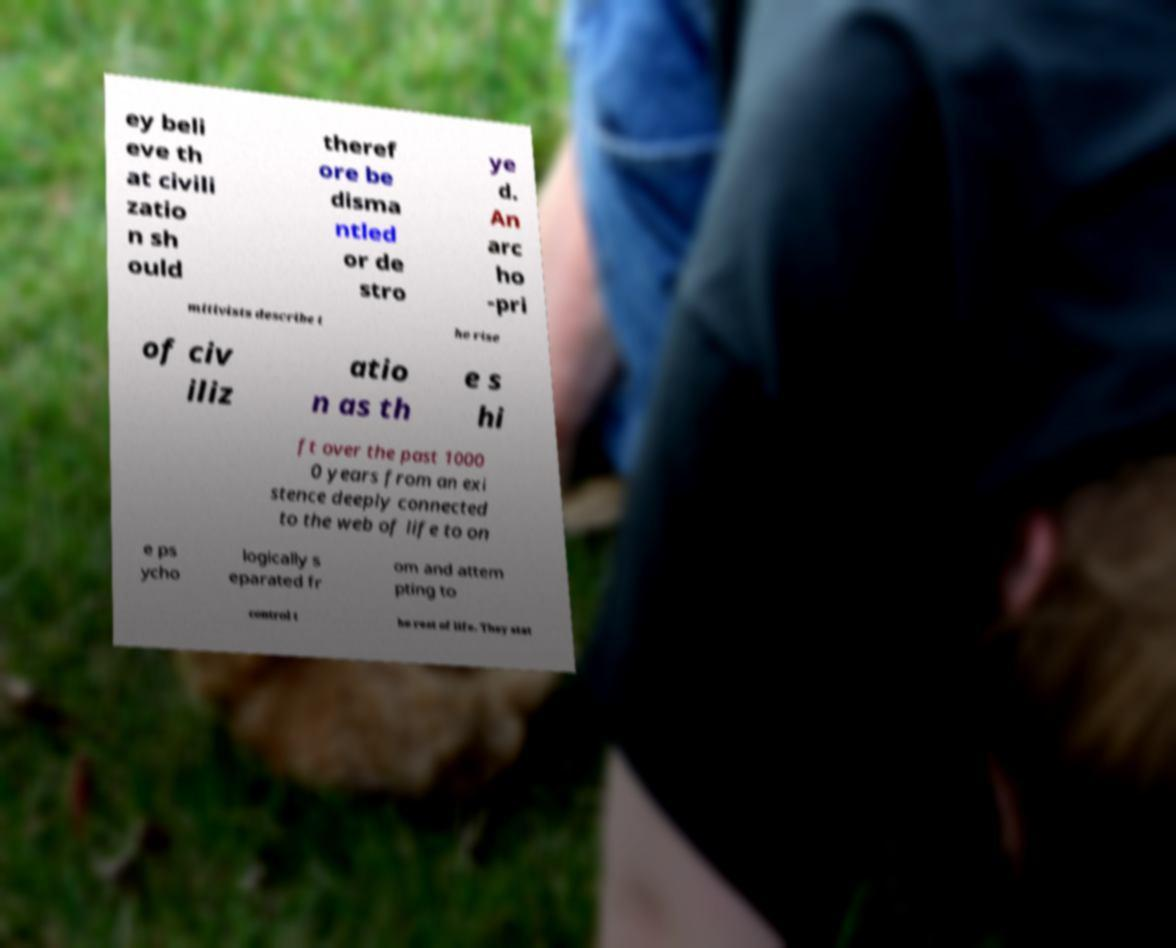I need the written content from this picture converted into text. Can you do that? ey beli eve th at civili zatio n sh ould theref ore be disma ntled or de stro ye d. An arc ho -pri mitivists describe t he rise of civ iliz atio n as th e s hi ft over the past 1000 0 years from an exi stence deeply connected to the web of life to on e ps ycho logically s eparated fr om and attem pting to control t he rest of life. They stat 